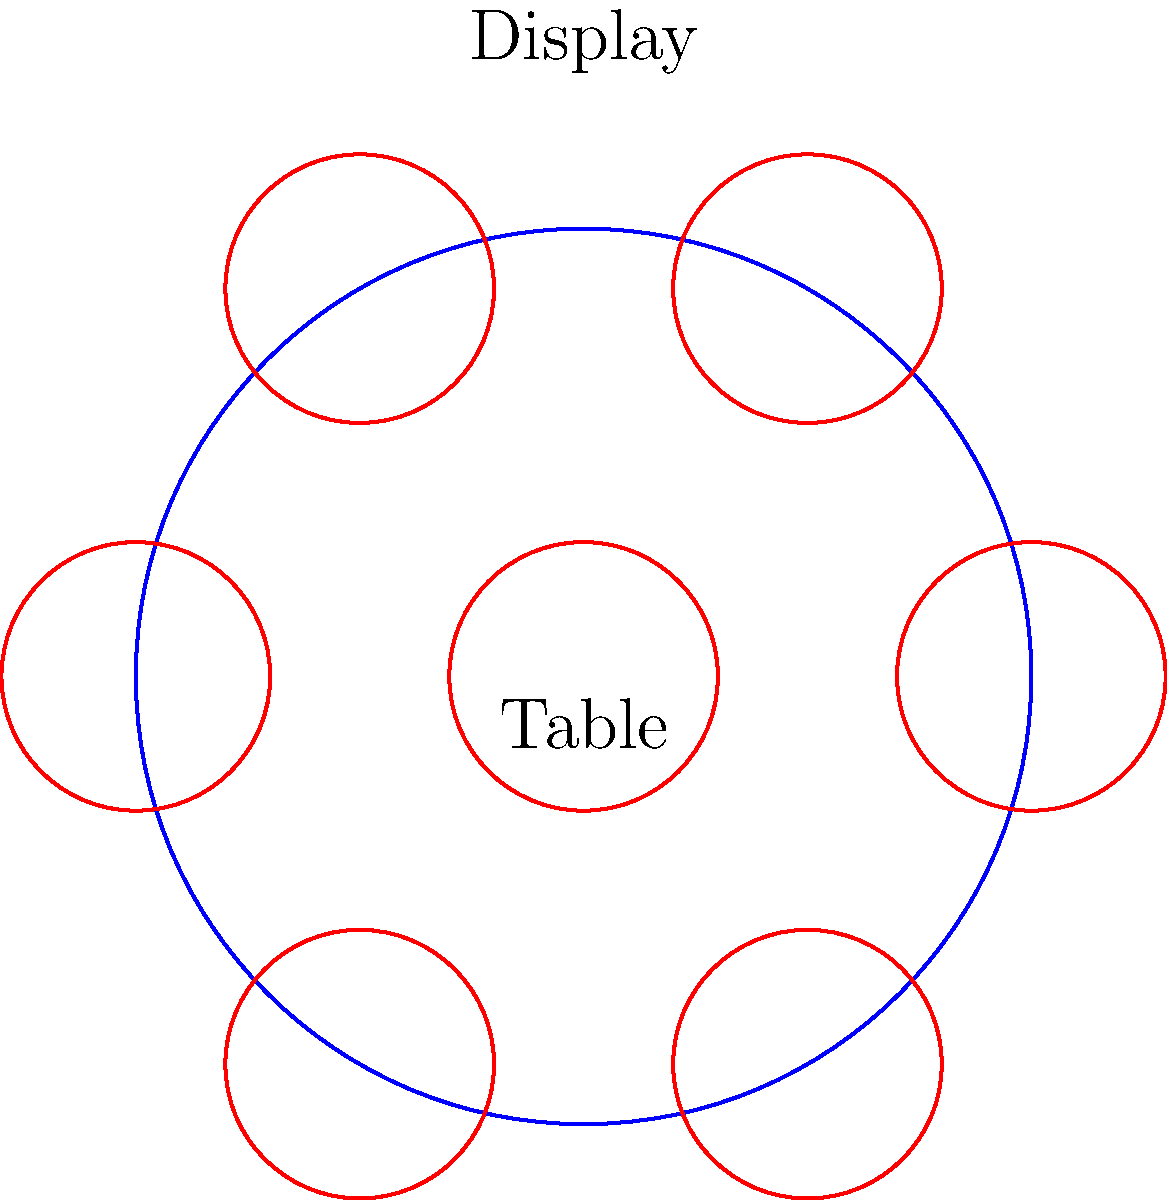As an entrepreneur optimizing product showcasing, you're arranging conical display stands on a circular table. The table has a radius of 5 meters, and each display stand has a base radius of 1.5 meters. What's the maximum number of display stands that can be placed around the edge of the table without overlapping, while maintaining symmetry? To solve this problem, we need to follow these steps:

1) First, we need to understand that the centers of the display stands will form a regular polygon inscribed in a circle. The radius of this circle will be the radius of the table minus the radius of a display stand:

   $R = 5 - 1.5 = 3.5$ meters

2) The problem of fitting the maximum number of circles around a larger circle is equivalent to finding the maximum number of equal chords that can fit around the circumference of the circle.

3) The central angle $\theta$ between two adjacent display stands is given by:

   $\theta = 2 \arcsin(\frac{r}{R})$

   where $r$ is the radius of a display stand (1.5m) and $R$ is the radius we calculated in step 1 (3.5m).

4) Calculating:

   $\theta = 2 \arcsin(\frac{1.5}{3.5}) \approx 0.8779$ radians

5) The maximum number of display stands $n$ is found by dividing the full circle (2π radians) by this angle:

   $n = \frac{2\pi}{\theta} \approx \frac{2\pi}{0.8779} \approx 7.16$

6) Since we need a whole number of display stands and we're looking for the maximum number while maintaining symmetry, we round down to 6.

Therefore, the maximum number of display stands that can be symmetrically arranged around the table is 6.
Answer: 6 display stands 